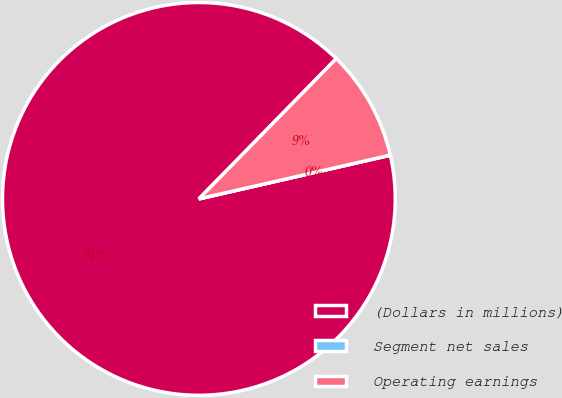Convert chart. <chart><loc_0><loc_0><loc_500><loc_500><pie_chart><fcel>(Dollars in millions)<fcel>Segment net sales<fcel>Operating earnings<nl><fcel>90.91%<fcel>0.0%<fcel>9.09%<nl></chart> 